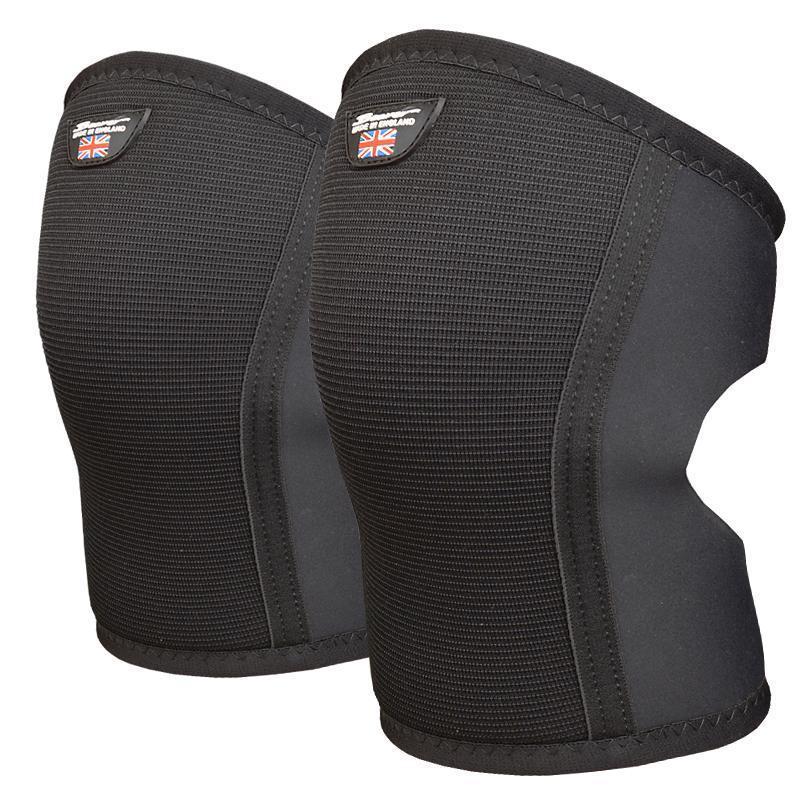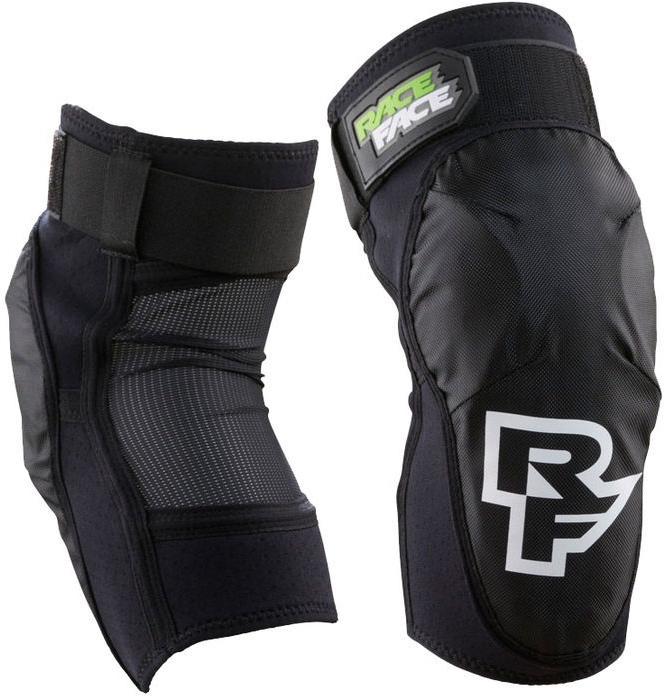The first image is the image on the left, the second image is the image on the right. For the images displayed, is the sentence "The right image shows a right-turned pair of pads, and the left image shows front and back views of a pair of pads." factually correct? Answer yes or no. No. The first image is the image on the left, the second image is the image on the right. Examine the images to the left and right. Is the description "One of the knee pads has a white logo on the bottom" accurate? Answer yes or no. Yes. 